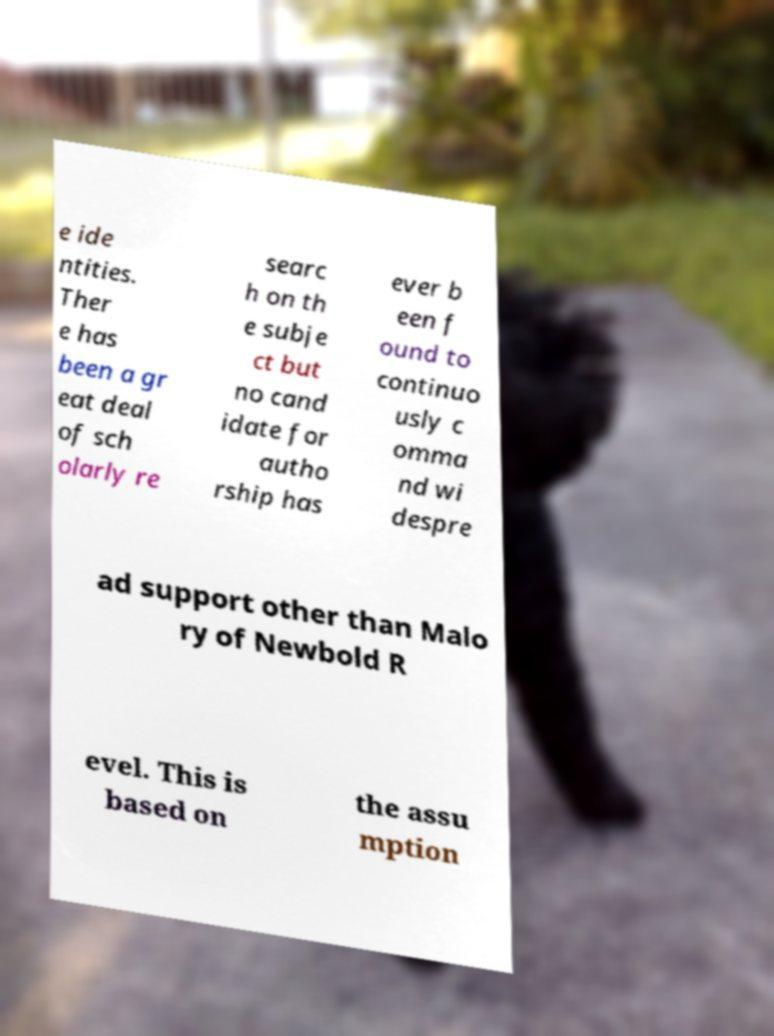Can you read and provide the text displayed in the image?This photo seems to have some interesting text. Can you extract and type it out for me? e ide ntities. Ther e has been a gr eat deal of sch olarly re searc h on th e subje ct but no cand idate for autho rship has ever b een f ound to continuo usly c omma nd wi despre ad support other than Malo ry of Newbold R evel. This is based on the assu mption 